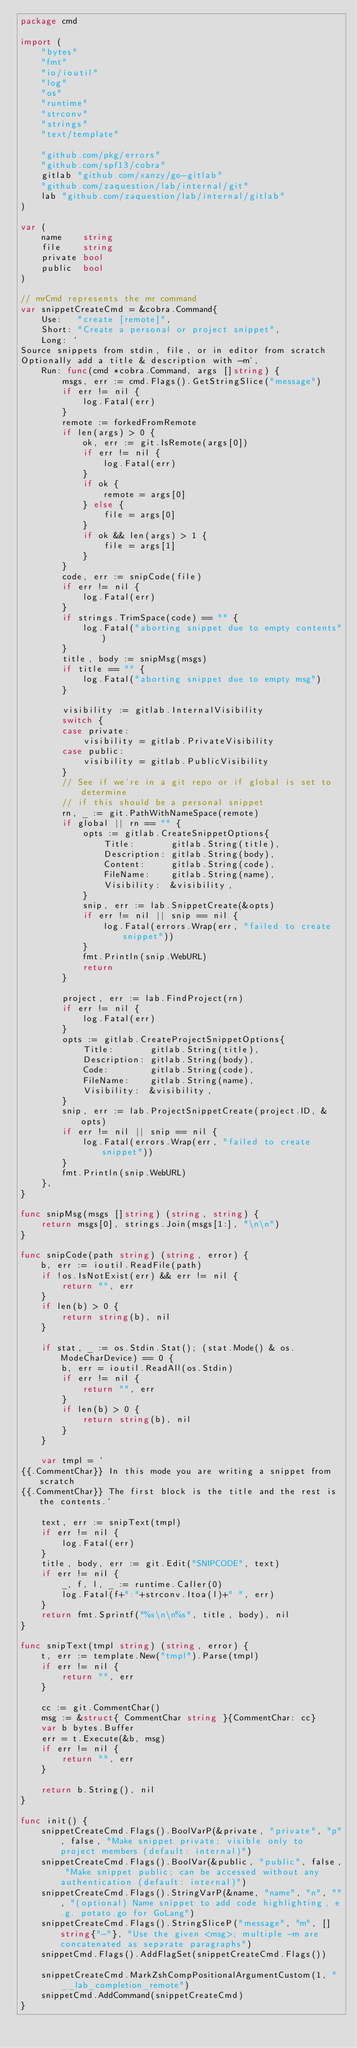<code> <loc_0><loc_0><loc_500><loc_500><_Go_>package cmd

import (
	"bytes"
	"fmt"
	"io/ioutil"
	"log"
	"os"
	"runtime"
	"strconv"
	"strings"
	"text/template"

	"github.com/pkg/errors"
	"github.com/spf13/cobra"
	gitlab "github.com/xanzy/go-gitlab"
	"github.com/zaquestion/lab/internal/git"
	lab "github.com/zaquestion/lab/internal/gitlab"
)

var (
	name    string
	file    string
	private bool
	public  bool
)

// mrCmd represents the mr command
var snippetCreateCmd = &cobra.Command{
	Use:   "create [remote]",
	Short: "Create a personal or project snippet",
	Long: `
Source snippets from stdin, file, or in editor from scratch
Optionally add a title & description with -m`,
	Run: func(cmd *cobra.Command, args []string) {
		msgs, err := cmd.Flags().GetStringSlice("message")
		if err != nil {
			log.Fatal(err)
		}
		remote := forkedFromRemote
		if len(args) > 0 {
			ok, err := git.IsRemote(args[0])
			if err != nil {
				log.Fatal(err)
			}
			if ok {
				remote = args[0]
			} else {
				file = args[0]
			}
			if ok && len(args) > 1 {
				file = args[1]
			}
		}
		code, err := snipCode(file)
		if err != nil {
			log.Fatal(err)
		}
		if strings.TrimSpace(code) == "" {
			log.Fatal("aborting snippet due to empty contents")
		}
		title, body := snipMsg(msgs)
		if title == "" {
			log.Fatal("aborting snippet due to empty msg")
		}

		visibility := gitlab.InternalVisibility
		switch {
		case private:
			visibility = gitlab.PrivateVisibility
		case public:
			visibility = gitlab.PublicVisibility
		}
		// See if we're in a git repo or if global is set to determine
		// if this should be a personal snippet
		rn, _ := git.PathWithNameSpace(remote)
		if global || rn == "" {
			opts := gitlab.CreateSnippetOptions{
				Title:       gitlab.String(title),
				Description: gitlab.String(body),
				Content:     gitlab.String(code),
				FileName:    gitlab.String(name),
				Visibility:  &visibility,
			}
			snip, err := lab.SnippetCreate(&opts)
			if err != nil || snip == nil {
				log.Fatal(errors.Wrap(err, "failed to create snippet"))
			}
			fmt.Println(snip.WebURL)
			return
		}

		project, err := lab.FindProject(rn)
		if err != nil {
			log.Fatal(err)
		}
		opts := gitlab.CreateProjectSnippetOptions{
			Title:       gitlab.String(title),
			Description: gitlab.String(body),
			Code:        gitlab.String(code),
			FileName:    gitlab.String(name),
			Visibility:  &visibility,
		}
		snip, err := lab.ProjectSnippetCreate(project.ID, &opts)
		if err != nil || snip == nil {
			log.Fatal(errors.Wrap(err, "failed to create snippet"))
		}
		fmt.Println(snip.WebURL)
	},
}

func snipMsg(msgs []string) (string, string) {
	return msgs[0], strings.Join(msgs[1:], "\n\n")
}

func snipCode(path string) (string, error) {
	b, err := ioutil.ReadFile(path)
	if !os.IsNotExist(err) && err != nil {
		return "", err
	}
	if len(b) > 0 {
		return string(b), nil
	}

	if stat, _ := os.Stdin.Stat(); (stat.Mode() & os.ModeCharDevice) == 0 {
		b, err = ioutil.ReadAll(os.Stdin)
		if err != nil {
			return "", err
		}
		if len(b) > 0 {
			return string(b), nil
		}
	}

	var tmpl = `
{{.CommentChar}} In this mode you are writing a snippet from scratch
{{.CommentChar}} The first block is the title and the rest is the contents.`

	text, err := snipText(tmpl)
	if err != nil {
		log.Fatal(err)
	}
	title, body, err := git.Edit("SNIPCODE", text)
	if err != nil {
		_, f, l, _ := runtime.Caller(0)
		log.Fatal(f+":"+strconv.Itoa(l)+" ", err)
	}
	return fmt.Sprintf("%s\n\n%s", title, body), nil
}

func snipText(tmpl string) (string, error) {
	t, err := template.New("tmpl").Parse(tmpl)
	if err != nil {
		return "", err
	}

	cc := git.CommentChar()
	msg := &struct{ CommentChar string }{CommentChar: cc}
	var b bytes.Buffer
	err = t.Execute(&b, msg)
	if err != nil {
		return "", err
	}

	return b.String(), nil
}

func init() {
	snippetCreateCmd.Flags().BoolVarP(&private, "private", "p", false, "Make snippet private; visible only to project members (default: internal)")
	snippetCreateCmd.Flags().BoolVar(&public, "public", false, "Make snippet public; can be accessed without any authentication (default: internal)")
	snippetCreateCmd.Flags().StringVarP(&name, "name", "n", "", "(optional) Name snippet to add code highlighting, e.g. potato.go for GoLang")
	snippetCreateCmd.Flags().StringSliceP("message", "m", []string{"-"}, "Use the given <msg>; multiple -m are concatenated as separate paragraphs")
	snippetCmd.Flags().AddFlagSet(snippetCreateCmd.Flags())

	snippetCreateCmd.MarkZshCompPositionalArgumentCustom(1, "__lab_completion_remote")
	snippetCmd.AddCommand(snippetCreateCmd)
}
</code> 